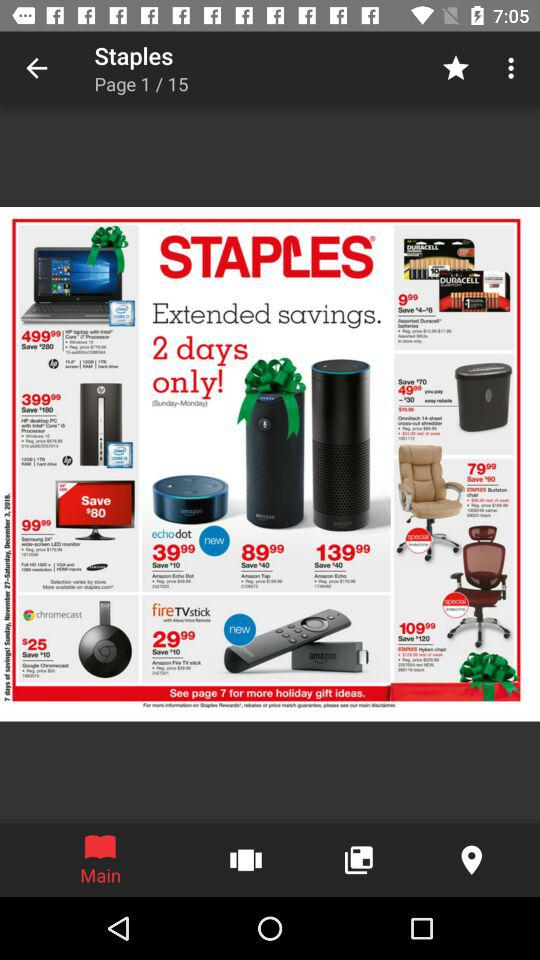What's the current page number? The current page number is 1. 